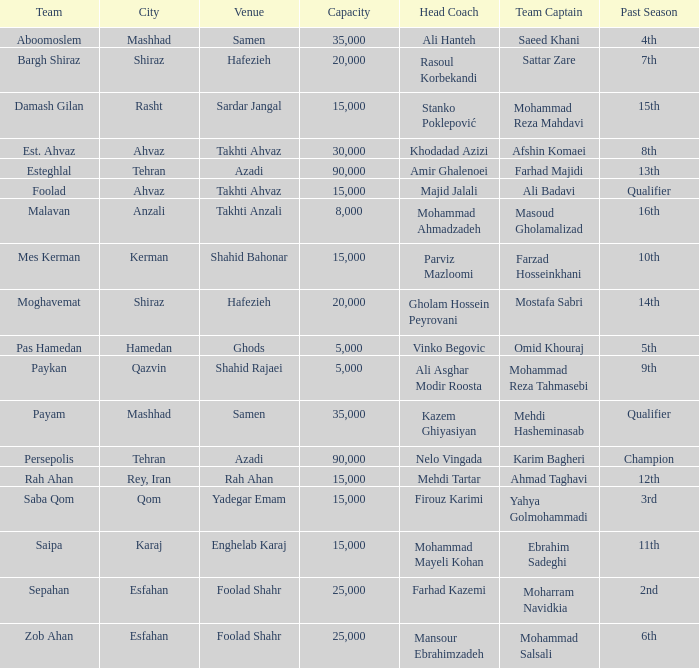Which location has a previous season of 2nd place? Foolad Shahr. 